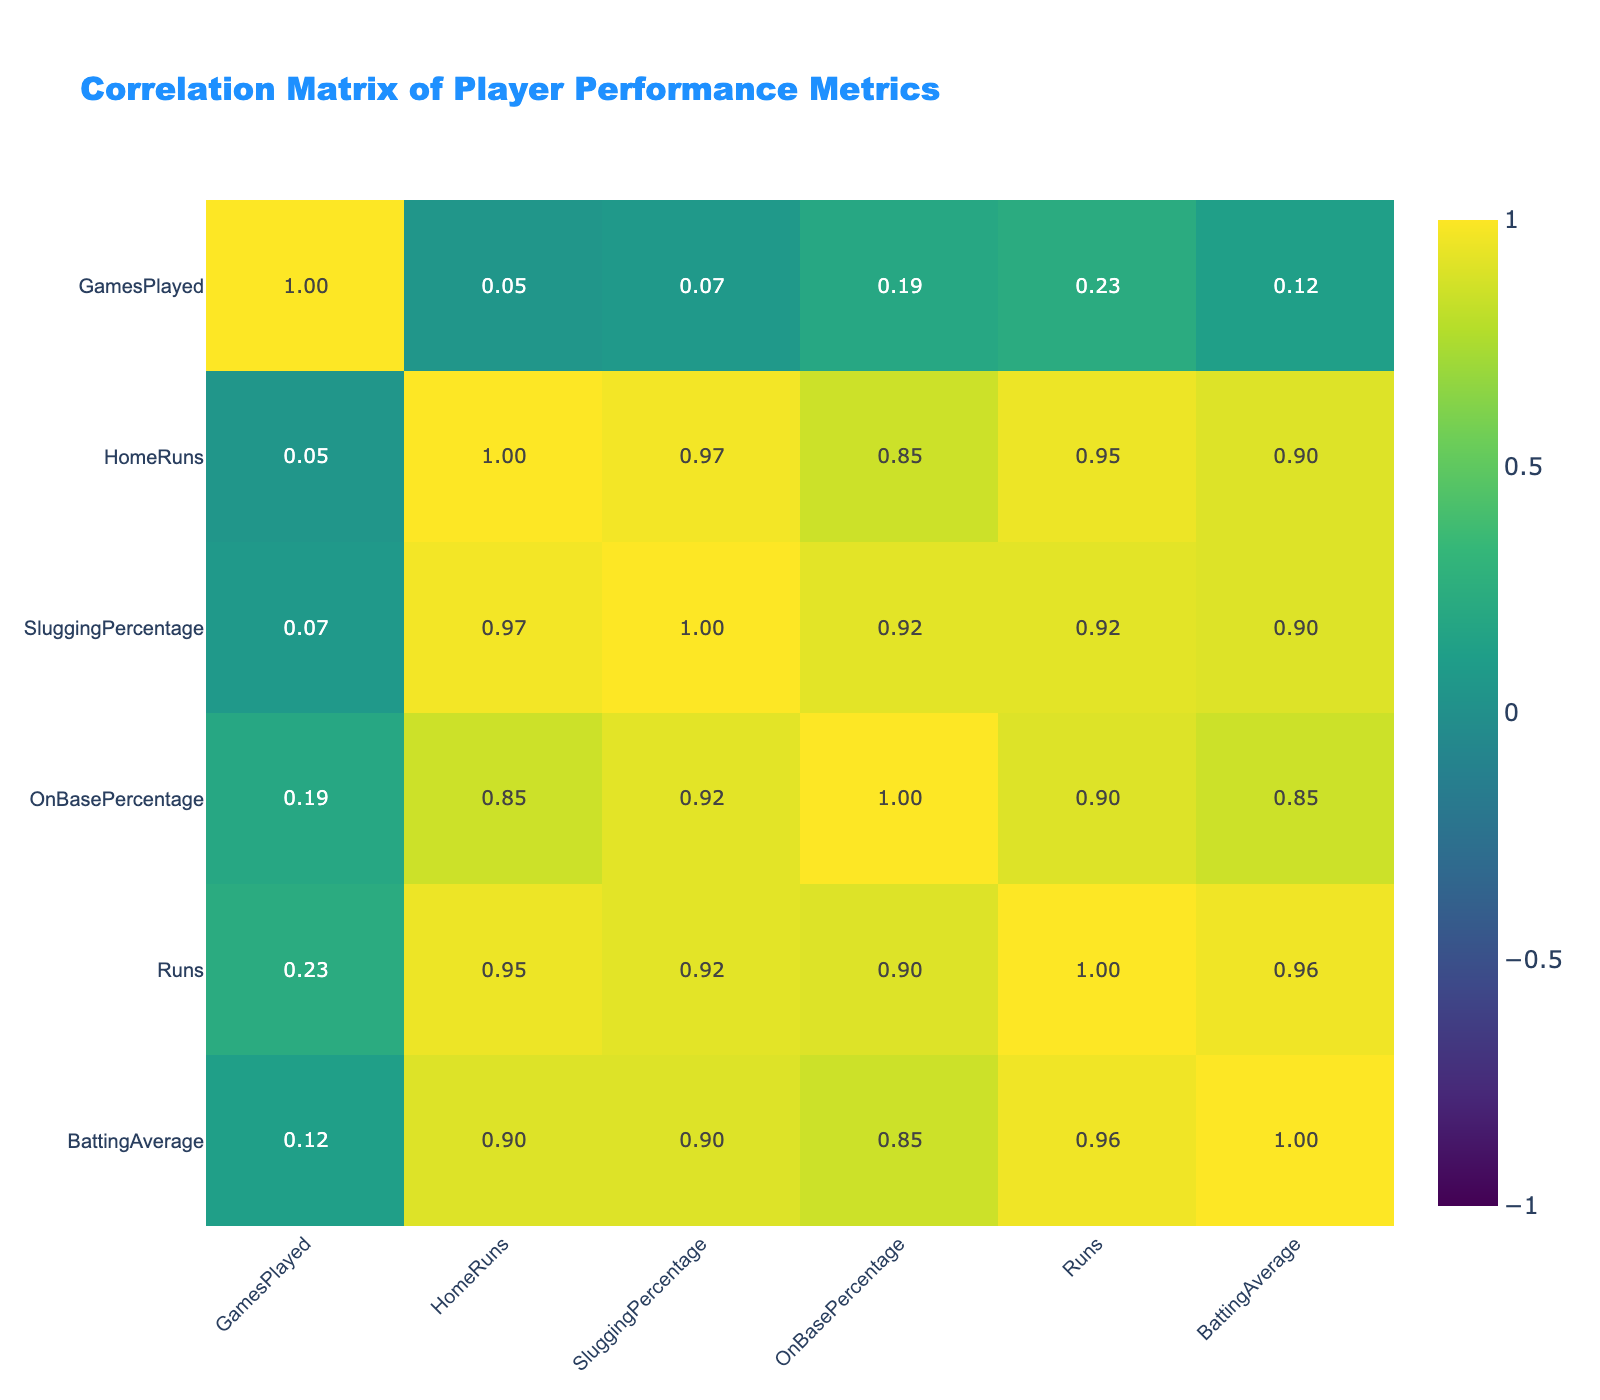What is the highest batting average among the players? By examining the BattingAverage column, the highest value is found for Leonardo Silva, who has a batting average of 0.318.
Answer: 0.318 Which player had the most home runs? In the HomeRuns column, comparing all the values shows that Leonardo Silva had the highest number with 30 home runs.
Answer: Leonardo Silva What is the correlation between Runs and HomeRuns? The correlation table indicates a positive correlation value of 0.89 between Runs and HomeRuns. This suggests a strong relationship where more home runs typically lead to more runs scored.
Answer: 0.89 What is the average slugging percentage of players who won more games than they lost? Looking at players with a WinLossRecord indicating more wins than losses, we find Juan Martinez (0.539), Leonardo Silva (0.621), Enrique Vargas (0.575), and Marco Rossi (0.515). The sum of their slugging percentages is (0.539 + 0.621 + 0.575 + 0.515) = 2.250. There are 4 players, so the average slugging percentage is 2.250 / 4 = 0.5625.
Answer: 0.5625 Is there a negative correlation between Batting Average and OnBasePercentage? Checking the table, the correlation value between BattingAverage and OnBasePercentage is 0.39, which is positive. This means there is no negative correlation; rather, they have a moderate positive relationship.
Answer: No Which player had the lowest runs scored and what was their GamesPlayed? From the Runs column, Tomoko Yoshida had the lowest runs with 55. Looking at the corresponding GamesPlayed, Tomoko Yoshida played 105 games.
Answer: Tomoko Yoshida, 105 What is the difference in home runs between the player with the highest and lowest home runs? The player with the highest home runs is Leonardo Silva with 30, and the player with the lowest home runs is Samuel Johnson with 14. The difference is 30 - 14 = 16 home runs.
Answer: 16 Are players with a higher OnBasePercentage more likely to have a higher SluggingPercentage based on this data? The correlation value between OnBasePercentage and SluggingPercentage is approximately 0.91, indicating a strong positive relationship. This suggests that players with a higher OnBasePercentage tend to also have a higher SluggingPercentage.
Answer: Yes 